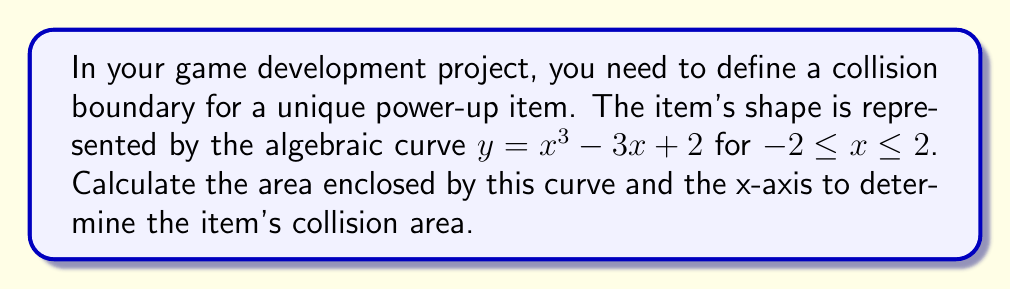Can you answer this question? To find the area enclosed by the curve $y = x^3 - 3x + 2$ and the x-axis, we need to follow these steps:

1. Identify the points where the curve intersects the x-axis:
   Set $y = 0$ and solve for x:
   $0 = x^3 - 3x + 2$
   $x^3 - 3x + 2 = 0$
   This equation has roots at $x = -1, 1, 2$

2. The area we need to calculate is split into two regions:
   Region 1: from $x = -1$ to $x = 1$ (above the x-axis)
   Region 2: from $x = 1$ to $x = 2$ (below the x-axis)

3. Use the definite integral to calculate the areas:
   Area = $\int_{-1}^1 (x^3 - 3x + 2) dx - \int_1^2 (x^3 - 3x + 2) dx$

4. Solve the integrals:
   $\int (x^3 - 3x + 2) dx = \frac{1}{4}x^4 - \frac{3}{2}x^2 + 2x + C$

   Area = $[\frac{1}{4}x^4 - \frac{3}{2}x^2 + 2x]_{-1}^1 - [\frac{1}{4}x^4 - \frac{3}{2}x^2 + 2x]_1^2$

5. Evaluate the definite integrals:
   Area = $(\frac{1}{4} - \frac{3}{2} + 2) - (-\frac{1}{4} + \frac{3}{2} - 2)$
        $- (4 - 6 + 4) + (\frac{1}{4} - \frac{3}{2} + 2)$
   
   Area = $(\frac{3}{4} + \frac{3}{2} + 4) - (2 - \frac{5}{4})$
   
   Area = $\frac{25}{4} - \frac{3}{4} = \frac{22}{4} = \frac{11}{2}$

Thus, the area enclosed by the curve is $\frac{11}{2}$ square units.
Answer: $\frac{11}{2}$ square units 